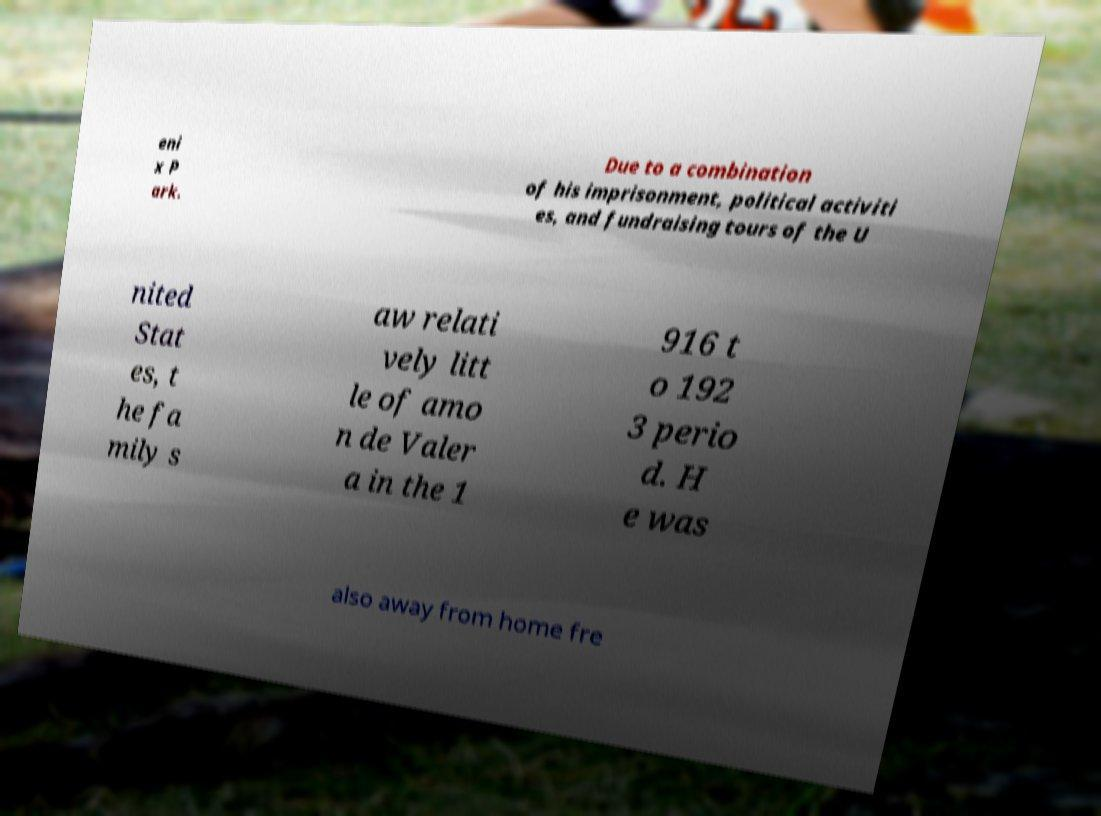Can you accurately transcribe the text from the provided image for me? eni x P ark. Due to a combination of his imprisonment, political activiti es, and fundraising tours of the U nited Stat es, t he fa mily s aw relati vely litt le of amo n de Valer a in the 1 916 t o 192 3 perio d. H e was also away from home fre 